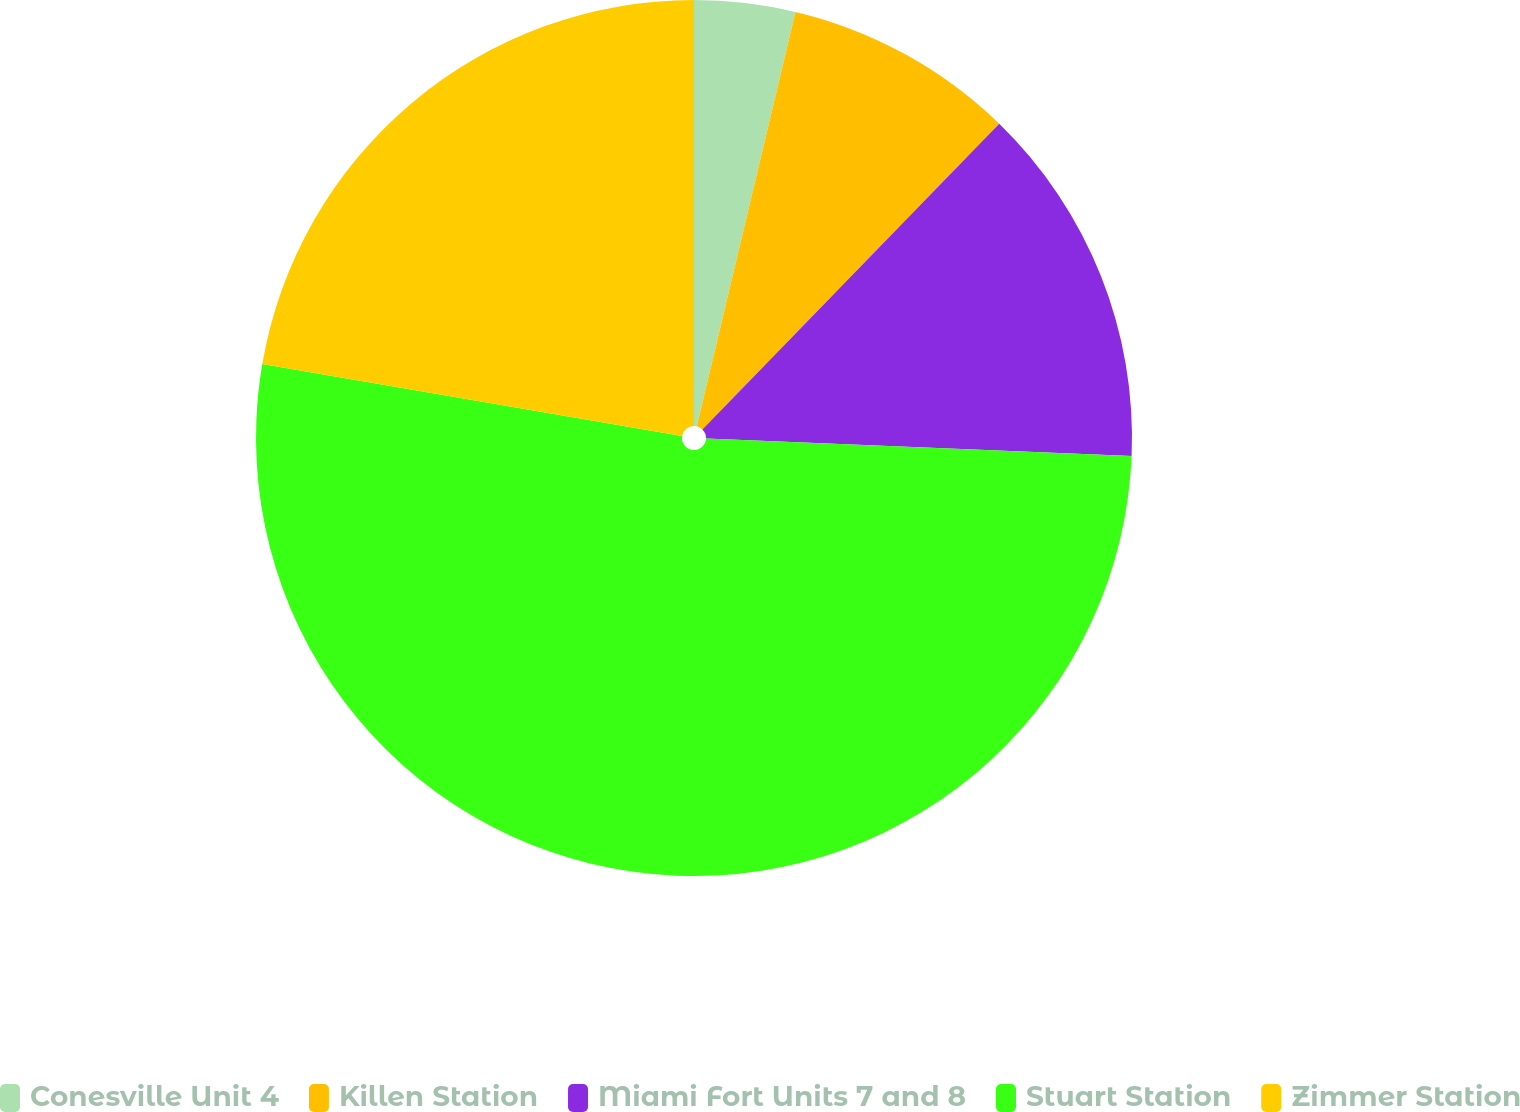<chart> <loc_0><loc_0><loc_500><loc_500><pie_chart><fcel>Conesville Unit 4<fcel>Killen Station<fcel>Miami Fort Units 7 and 8<fcel>Stuart Station<fcel>Zimmer Station<nl><fcel>3.72%<fcel>8.55%<fcel>13.38%<fcel>52.04%<fcel>22.3%<nl></chart> 